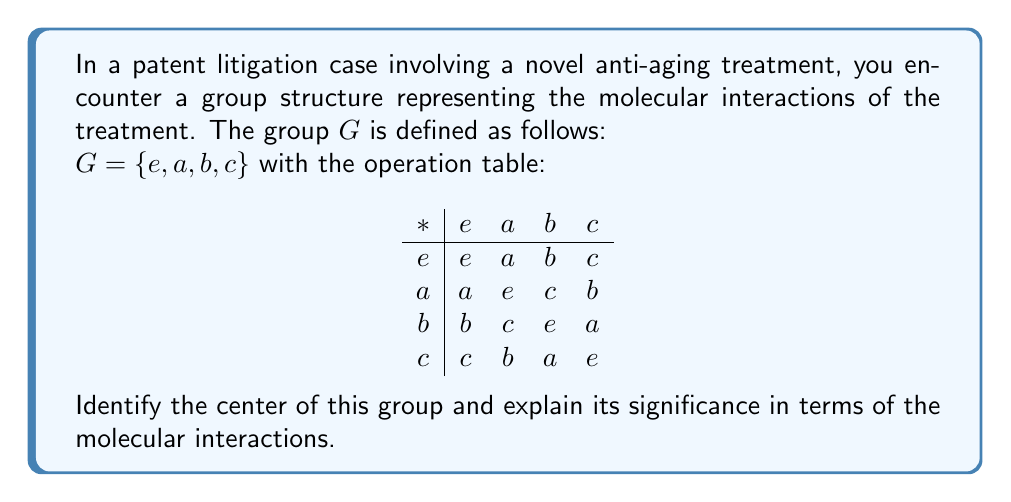Teach me how to tackle this problem. To find the center of the group $G$, we need to identify all elements that commute with every other element in the group. Let's follow these steps:

1) First, recall that the center of a group $G$ is defined as:
   $Z(G) = \{z \in G : zg = gz \text{ for all } g \in G\}$

2) We need to check each element's commutativity with all other elements:

   For $e$:
   - $e * g = g * e$ for all $g \in G$ (identity property)

   For $a$:
   - $a * e = e * a = a$
   - $a * a = a * a = e$
   - $a * b = c \neq b = b * a$
   - $a * c = b \neq c = c * a$

   For $b$:
   - $b * e = e * b = b$
   - $b * a = c \neq a = a * b$
   - $b * b = b * b = e$
   - $b * c = a \neq c = c * b$

   For $c$:
   - $c * e = e * c = c$
   - $c * a = b \neq a = a * c$
   - $c * b = a \neq b = b * c$
   - $c * c = c * c = e$

3) From this analysis, we can see that only $e$ commutes with all elements of $G$.

4) Therefore, the center of the group is $Z(G) = \{e\}$.

In terms of molecular interactions, the center represents the components of the anti-aging treatment that interact uniformly with all other components. In this case, only the identity element $e$ has this property, which could represent a neutral or non-reactive component in the treatment.
Answer: $Z(G) = \{e\}$ 